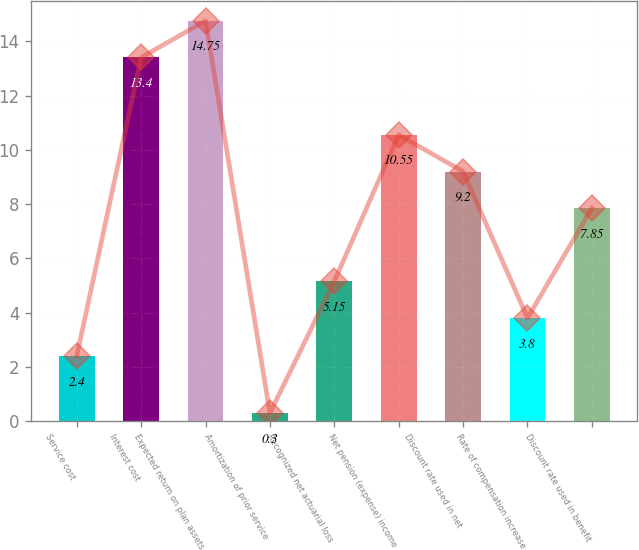<chart> <loc_0><loc_0><loc_500><loc_500><bar_chart><fcel>Service cost<fcel>Interest cost<fcel>Expected return on plan assets<fcel>Amortization of prior service<fcel>Recognized net actuarial loss<fcel>Net pension (expense) income<fcel>Discount rate used in net<fcel>Rate of compensation increase<fcel>Discount rate used in benefit<nl><fcel>2.4<fcel>13.4<fcel>14.75<fcel>0.3<fcel>5.15<fcel>10.55<fcel>9.2<fcel>3.8<fcel>7.85<nl></chart> 